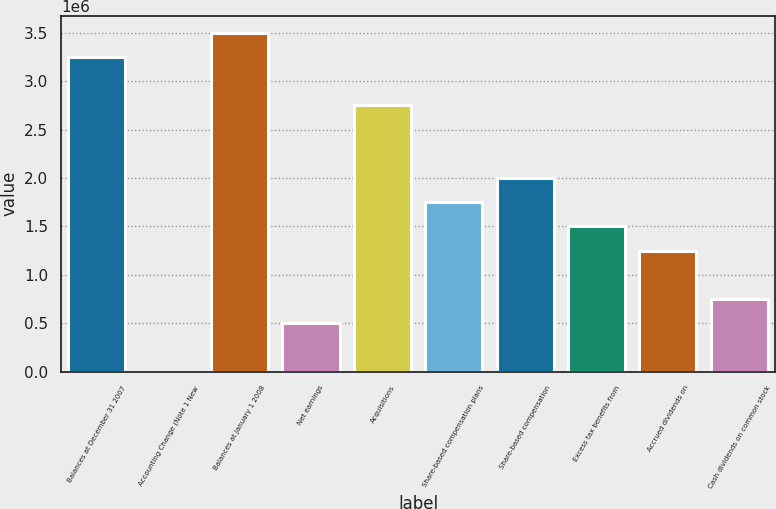Convert chart to OTSL. <chart><loc_0><loc_0><loc_500><loc_500><bar_chart><fcel>Balances at December 31 2007<fcel>Accounting Change (Note 1 New<fcel>Balances at January 1 2008<fcel>Net earnings<fcel>Acquisitions<fcel>Share-based compensation plans<fcel>Share-based compensation<fcel>Excess tax benefits from<fcel>Accrued dividends on<fcel>Cash dividends on common stock<nl><fcel>3.25115e+06<fcel>1.56<fcel>3.50124e+06<fcel>500178<fcel>2.75097e+06<fcel>1.75062e+06<fcel>2.00071e+06<fcel>1.50053e+06<fcel>1.25044e+06<fcel>750267<nl></chart> 